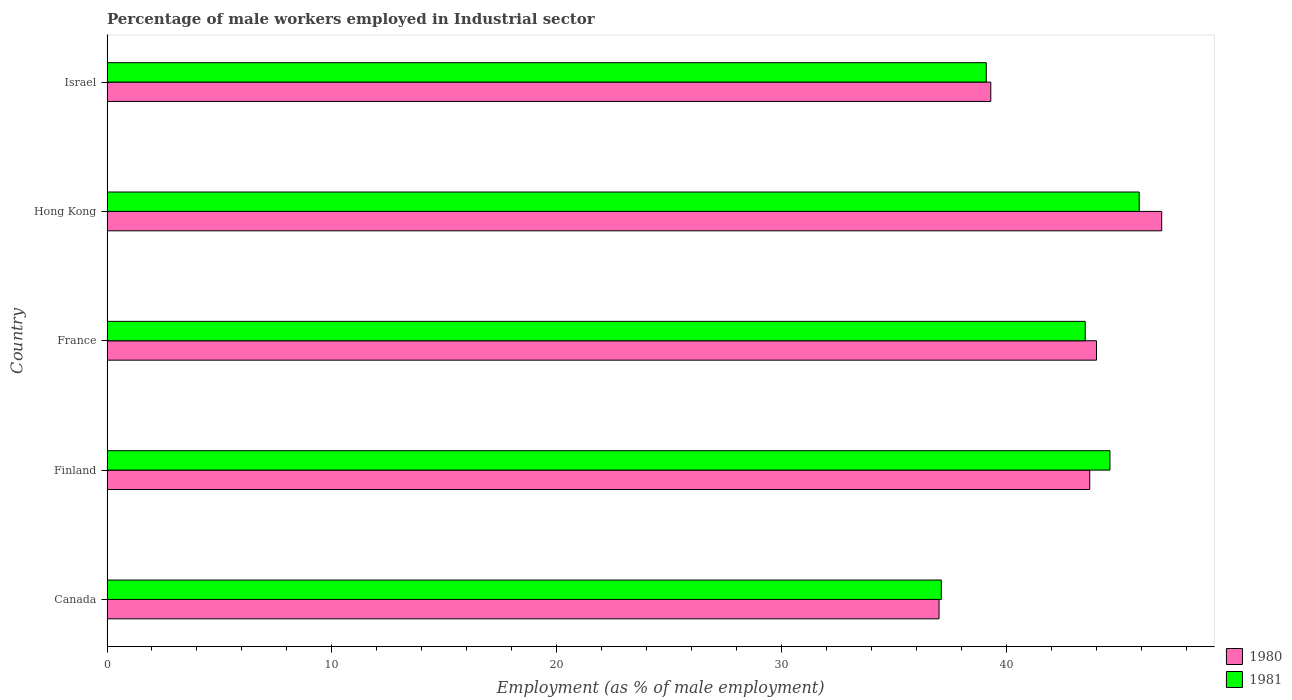How many different coloured bars are there?
Give a very brief answer. 2. How many groups of bars are there?
Ensure brevity in your answer.  5. Are the number of bars on each tick of the Y-axis equal?
Offer a very short reply. Yes. What is the percentage of male workers employed in Industrial sector in 1980 in Israel?
Ensure brevity in your answer.  39.3. Across all countries, what is the maximum percentage of male workers employed in Industrial sector in 1980?
Ensure brevity in your answer.  46.9. Across all countries, what is the minimum percentage of male workers employed in Industrial sector in 1981?
Provide a short and direct response. 37.1. In which country was the percentage of male workers employed in Industrial sector in 1981 maximum?
Provide a succinct answer. Hong Kong. In which country was the percentage of male workers employed in Industrial sector in 1981 minimum?
Offer a very short reply. Canada. What is the total percentage of male workers employed in Industrial sector in 1980 in the graph?
Make the answer very short. 210.9. What is the difference between the percentage of male workers employed in Industrial sector in 1980 in Hong Kong and that in Israel?
Provide a short and direct response. 7.6. What is the difference between the percentage of male workers employed in Industrial sector in 1980 in Hong Kong and the percentage of male workers employed in Industrial sector in 1981 in Israel?
Provide a short and direct response. 7.8. What is the average percentage of male workers employed in Industrial sector in 1981 per country?
Keep it short and to the point. 42.04. What is the difference between the percentage of male workers employed in Industrial sector in 1980 and percentage of male workers employed in Industrial sector in 1981 in France?
Offer a very short reply. 0.5. In how many countries, is the percentage of male workers employed in Industrial sector in 1981 greater than 24 %?
Your answer should be very brief. 5. What is the ratio of the percentage of male workers employed in Industrial sector in 1980 in Finland to that in France?
Offer a very short reply. 0.99. Is the percentage of male workers employed in Industrial sector in 1981 in Finland less than that in Israel?
Provide a short and direct response. No. Is the difference between the percentage of male workers employed in Industrial sector in 1980 in Canada and France greater than the difference between the percentage of male workers employed in Industrial sector in 1981 in Canada and France?
Your response must be concise. No. What is the difference between the highest and the second highest percentage of male workers employed in Industrial sector in 1981?
Provide a succinct answer. 1.3. What is the difference between the highest and the lowest percentage of male workers employed in Industrial sector in 1980?
Your answer should be very brief. 9.9. What does the 2nd bar from the bottom in Hong Kong represents?
Provide a succinct answer. 1981. How many bars are there?
Keep it short and to the point. 10. Are all the bars in the graph horizontal?
Provide a short and direct response. Yes. Are the values on the major ticks of X-axis written in scientific E-notation?
Ensure brevity in your answer.  No. Does the graph contain grids?
Make the answer very short. No. Where does the legend appear in the graph?
Offer a terse response. Bottom right. What is the title of the graph?
Your answer should be compact. Percentage of male workers employed in Industrial sector. What is the label or title of the X-axis?
Provide a short and direct response. Employment (as % of male employment). What is the Employment (as % of male employment) in 1981 in Canada?
Offer a terse response. 37.1. What is the Employment (as % of male employment) of 1980 in Finland?
Ensure brevity in your answer.  43.7. What is the Employment (as % of male employment) in 1981 in Finland?
Your response must be concise. 44.6. What is the Employment (as % of male employment) of 1981 in France?
Provide a succinct answer. 43.5. What is the Employment (as % of male employment) in 1980 in Hong Kong?
Keep it short and to the point. 46.9. What is the Employment (as % of male employment) in 1981 in Hong Kong?
Keep it short and to the point. 45.9. What is the Employment (as % of male employment) of 1980 in Israel?
Provide a succinct answer. 39.3. What is the Employment (as % of male employment) of 1981 in Israel?
Provide a short and direct response. 39.1. Across all countries, what is the maximum Employment (as % of male employment) in 1980?
Your response must be concise. 46.9. Across all countries, what is the maximum Employment (as % of male employment) in 1981?
Make the answer very short. 45.9. Across all countries, what is the minimum Employment (as % of male employment) of 1980?
Ensure brevity in your answer.  37. Across all countries, what is the minimum Employment (as % of male employment) in 1981?
Keep it short and to the point. 37.1. What is the total Employment (as % of male employment) of 1980 in the graph?
Keep it short and to the point. 210.9. What is the total Employment (as % of male employment) in 1981 in the graph?
Your answer should be compact. 210.2. What is the difference between the Employment (as % of male employment) of 1981 in Canada and that in Finland?
Provide a short and direct response. -7.5. What is the difference between the Employment (as % of male employment) in 1980 in Canada and that in France?
Keep it short and to the point. -7. What is the difference between the Employment (as % of male employment) of 1981 in Canada and that in Hong Kong?
Offer a very short reply. -8.8. What is the difference between the Employment (as % of male employment) of 1981 in Canada and that in Israel?
Your response must be concise. -2. What is the difference between the Employment (as % of male employment) in 1980 in Finland and that in Hong Kong?
Your answer should be compact. -3.2. What is the difference between the Employment (as % of male employment) of 1981 in Finland and that in Israel?
Provide a succinct answer. 5.5. What is the difference between the Employment (as % of male employment) in 1981 in France and that in Hong Kong?
Give a very brief answer. -2.4. What is the difference between the Employment (as % of male employment) of 1980 in France and that in Israel?
Give a very brief answer. 4.7. What is the difference between the Employment (as % of male employment) in 1981 in Hong Kong and that in Israel?
Provide a succinct answer. 6.8. What is the difference between the Employment (as % of male employment) in 1980 in Canada and the Employment (as % of male employment) in 1981 in France?
Make the answer very short. -6.5. What is the difference between the Employment (as % of male employment) of 1980 in Canada and the Employment (as % of male employment) of 1981 in Hong Kong?
Keep it short and to the point. -8.9. What is the difference between the Employment (as % of male employment) in 1980 in Canada and the Employment (as % of male employment) in 1981 in Israel?
Provide a short and direct response. -2.1. What is the difference between the Employment (as % of male employment) in 1980 in Finland and the Employment (as % of male employment) in 1981 in France?
Offer a terse response. 0.2. What is the difference between the Employment (as % of male employment) of 1980 in Finland and the Employment (as % of male employment) of 1981 in Hong Kong?
Your answer should be compact. -2.2. What is the difference between the Employment (as % of male employment) of 1980 in Finland and the Employment (as % of male employment) of 1981 in Israel?
Your response must be concise. 4.6. What is the difference between the Employment (as % of male employment) in 1980 in France and the Employment (as % of male employment) in 1981 in Hong Kong?
Keep it short and to the point. -1.9. What is the difference between the Employment (as % of male employment) in 1980 in France and the Employment (as % of male employment) in 1981 in Israel?
Give a very brief answer. 4.9. What is the average Employment (as % of male employment) of 1980 per country?
Your answer should be very brief. 42.18. What is the average Employment (as % of male employment) in 1981 per country?
Your answer should be very brief. 42.04. What is the difference between the Employment (as % of male employment) of 1980 and Employment (as % of male employment) of 1981 in Finland?
Provide a succinct answer. -0.9. What is the ratio of the Employment (as % of male employment) of 1980 in Canada to that in Finland?
Keep it short and to the point. 0.85. What is the ratio of the Employment (as % of male employment) in 1981 in Canada to that in Finland?
Your response must be concise. 0.83. What is the ratio of the Employment (as % of male employment) of 1980 in Canada to that in France?
Your answer should be very brief. 0.84. What is the ratio of the Employment (as % of male employment) in 1981 in Canada to that in France?
Provide a short and direct response. 0.85. What is the ratio of the Employment (as % of male employment) of 1980 in Canada to that in Hong Kong?
Ensure brevity in your answer.  0.79. What is the ratio of the Employment (as % of male employment) in 1981 in Canada to that in Hong Kong?
Your answer should be compact. 0.81. What is the ratio of the Employment (as % of male employment) of 1980 in Canada to that in Israel?
Give a very brief answer. 0.94. What is the ratio of the Employment (as % of male employment) in 1981 in Canada to that in Israel?
Offer a terse response. 0.95. What is the ratio of the Employment (as % of male employment) in 1981 in Finland to that in France?
Ensure brevity in your answer.  1.03. What is the ratio of the Employment (as % of male employment) in 1980 in Finland to that in Hong Kong?
Your response must be concise. 0.93. What is the ratio of the Employment (as % of male employment) in 1981 in Finland to that in Hong Kong?
Give a very brief answer. 0.97. What is the ratio of the Employment (as % of male employment) in 1980 in Finland to that in Israel?
Offer a terse response. 1.11. What is the ratio of the Employment (as % of male employment) in 1981 in Finland to that in Israel?
Your answer should be compact. 1.14. What is the ratio of the Employment (as % of male employment) in 1980 in France to that in Hong Kong?
Offer a very short reply. 0.94. What is the ratio of the Employment (as % of male employment) in 1981 in France to that in Hong Kong?
Make the answer very short. 0.95. What is the ratio of the Employment (as % of male employment) of 1980 in France to that in Israel?
Provide a short and direct response. 1.12. What is the ratio of the Employment (as % of male employment) of 1981 in France to that in Israel?
Your response must be concise. 1.11. What is the ratio of the Employment (as % of male employment) in 1980 in Hong Kong to that in Israel?
Your response must be concise. 1.19. What is the ratio of the Employment (as % of male employment) of 1981 in Hong Kong to that in Israel?
Offer a terse response. 1.17. What is the difference between the highest and the lowest Employment (as % of male employment) in 1980?
Your answer should be compact. 9.9. 